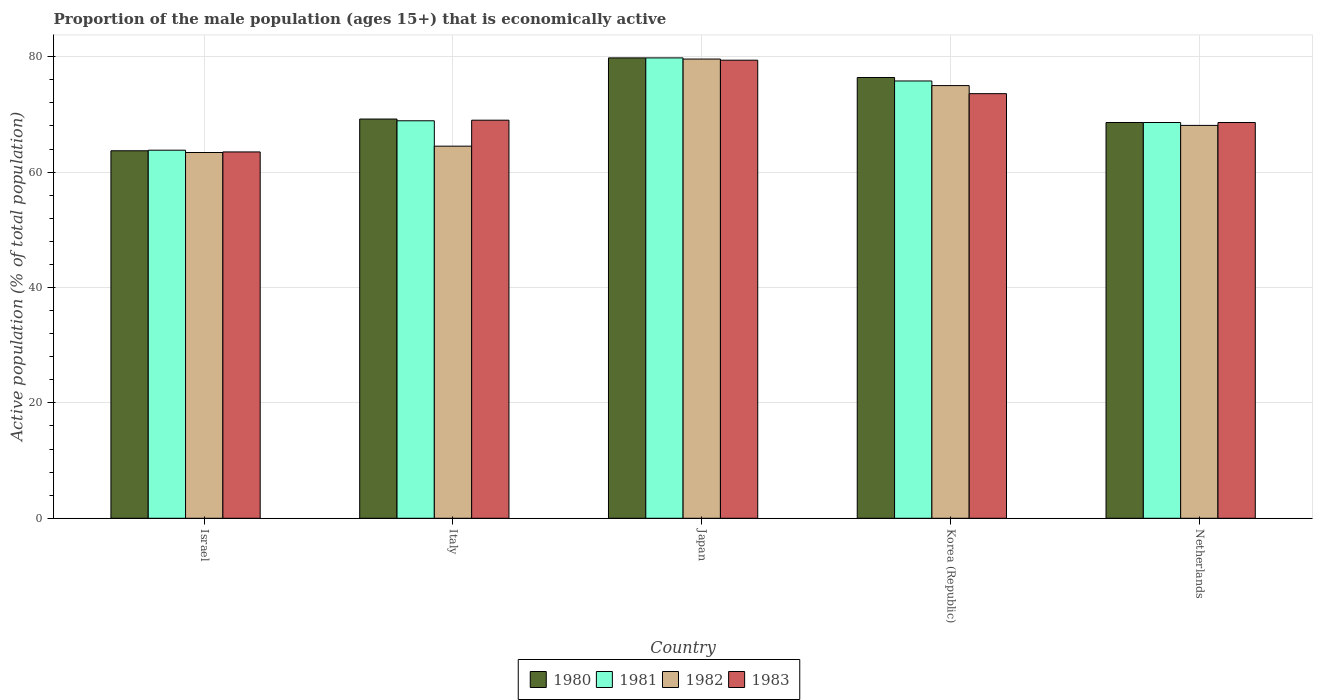How many groups of bars are there?
Ensure brevity in your answer.  5. How many bars are there on the 2nd tick from the left?
Your answer should be compact. 4. What is the label of the 2nd group of bars from the left?
Provide a succinct answer. Italy. What is the proportion of the male population that is economically active in 1983 in Israel?
Ensure brevity in your answer.  63.5. Across all countries, what is the maximum proportion of the male population that is economically active in 1983?
Keep it short and to the point. 79.4. Across all countries, what is the minimum proportion of the male population that is economically active in 1981?
Provide a short and direct response. 63.8. In which country was the proportion of the male population that is economically active in 1983 minimum?
Your response must be concise. Israel. What is the total proportion of the male population that is economically active in 1983 in the graph?
Your answer should be compact. 354.1. What is the difference between the proportion of the male population that is economically active in 1982 in Italy and that in Japan?
Give a very brief answer. -15.1. What is the difference between the proportion of the male population that is economically active in 1983 in Japan and the proportion of the male population that is economically active in 1982 in Netherlands?
Your response must be concise. 11.3. What is the average proportion of the male population that is economically active in 1980 per country?
Offer a very short reply. 71.54. What is the difference between the proportion of the male population that is economically active of/in 1980 and proportion of the male population that is economically active of/in 1983 in Japan?
Your answer should be compact. 0.4. What is the ratio of the proportion of the male population that is economically active in 1982 in Italy to that in Japan?
Offer a very short reply. 0.81. Is the proportion of the male population that is economically active in 1980 in Israel less than that in Japan?
Ensure brevity in your answer.  Yes. What is the difference between the highest and the second highest proportion of the male population that is economically active in 1981?
Your answer should be compact. 6.9. What is the difference between the highest and the lowest proportion of the male population that is economically active in 1980?
Offer a terse response. 16.1. Is the sum of the proportion of the male population that is economically active in 1980 in Israel and Japan greater than the maximum proportion of the male population that is economically active in 1983 across all countries?
Offer a very short reply. Yes. What does the 2nd bar from the right in Japan represents?
Offer a terse response. 1982. How many bars are there?
Offer a terse response. 20. Are the values on the major ticks of Y-axis written in scientific E-notation?
Give a very brief answer. No. What is the title of the graph?
Your answer should be very brief. Proportion of the male population (ages 15+) that is economically active. What is the label or title of the Y-axis?
Offer a terse response. Active population (% of total population). What is the Active population (% of total population) of 1980 in Israel?
Ensure brevity in your answer.  63.7. What is the Active population (% of total population) of 1981 in Israel?
Your answer should be compact. 63.8. What is the Active population (% of total population) of 1982 in Israel?
Your response must be concise. 63.4. What is the Active population (% of total population) of 1983 in Israel?
Give a very brief answer. 63.5. What is the Active population (% of total population) in 1980 in Italy?
Give a very brief answer. 69.2. What is the Active population (% of total population) in 1981 in Italy?
Your response must be concise. 68.9. What is the Active population (% of total population) of 1982 in Italy?
Your response must be concise. 64.5. What is the Active population (% of total population) of 1983 in Italy?
Give a very brief answer. 69. What is the Active population (% of total population) of 1980 in Japan?
Your answer should be very brief. 79.8. What is the Active population (% of total population) of 1981 in Japan?
Your answer should be compact. 79.8. What is the Active population (% of total population) of 1982 in Japan?
Make the answer very short. 79.6. What is the Active population (% of total population) in 1983 in Japan?
Ensure brevity in your answer.  79.4. What is the Active population (% of total population) in 1980 in Korea (Republic)?
Make the answer very short. 76.4. What is the Active population (% of total population) in 1981 in Korea (Republic)?
Ensure brevity in your answer.  75.8. What is the Active population (% of total population) in 1983 in Korea (Republic)?
Your answer should be very brief. 73.6. What is the Active population (% of total population) in 1980 in Netherlands?
Give a very brief answer. 68.6. What is the Active population (% of total population) in 1981 in Netherlands?
Offer a very short reply. 68.6. What is the Active population (% of total population) of 1982 in Netherlands?
Ensure brevity in your answer.  68.1. What is the Active population (% of total population) of 1983 in Netherlands?
Provide a succinct answer. 68.6. Across all countries, what is the maximum Active population (% of total population) in 1980?
Your answer should be compact. 79.8. Across all countries, what is the maximum Active population (% of total population) of 1981?
Make the answer very short. 79.8. Across all countries, what is the maximum Active population (% of total population) in 1982?
Keep it short and to the point. 79.6. Across all countries, what is the maximum Active population (% of total population) in 1983?
Make the answer very short. 79.4. Across all countries, what is the minimum Active population (% of total population) of 1980?
Give a very brief answer. 63.7. Across all countries, what is the minimum Active population (% of total population) of 1981?
Offer a terse response. 63.8. Across all countries, what is the minimum Active population (% of total population) of 1982?
Make the answer very short. 63.4. Across all countries, what is the minimum Active population (% of total population) in 1983?
Offer a very short reply. 63.5. What is the total Active population (% of total population) of 1980 in the graph?
Provide a short and direct response. 357.7. What is the total Active population (% of total population) in 1981 in the graph?
Provide a succinct answer. 356.9. What is the total Active population (% of total population) of 1982 in the graph?
Ensure brevity in your answer.  350.6. What is the total Active population (% of total population) of 1983 in the graph?
Your response must be concise. 354.1. What is the difference between the Active population (% of total population) of 1980 in Israel and that in Italy?
Keep it short and to the point. -5.5. What is the difference between the Active population (% of total population) of 1982 in Israel and that in Italy?
Your answer should be very brief. -1.1. What is the difference between the Active population (% of total population) of 1980 in Israel and that in Japan?
Provide a succinct answer. -16.1. What is the difference between the Active population (% of total population) in 1981 in Israel and that in Japan?
Ensure brevity in your answer.  -16. What is the difference between the Active population (% of total population) of 1982 in Israel and that in Japan?
Your answer should be very brief. -16.2. What is the difference between the Active population (% of total population) of 1983 in Israel and that in Japan?
Keep it short and to the point. -15.9. What is the difference between the Active population (% of total population) in 1980 in Israel and that in Korea (Republic)?
Your answer should be compact. -12.7. What is the difference between the Active population (% of total population) in 1982 in Israel and that in Korea (Republic)?
Offer a very short reply. -11.6. What is the difference between the Active population (% of total population) in 1983 in Israel and that in Korea (Republic)?
Keep it short and to the point. -10.1. What is the difference between the Active population (% of total population) of 1980 in Israel and that in Netherlands?
Keep it short and to the point. -4.9. What is the difference between the Active population (% of total population) in 1981 in Israel and that in Netherlands?
Make the answer very short. -4.8. What is the difference between the Active population (% of total population) of 1982 in Israel and that in Netherlands?
Your answer should be very brief. -4.7. What is the difference between the Active population (% of total population) of 1982 in Italy and that in Japan?
Your answer should be compact. -15.1. What is the difference between the Active population (% of total population) in 1983 in Italy and that in Japan?
Your response must be concise. -10.4. What is the difference between the Active population (% of total population) of 1981 in Italy and that in Korea (Republic)?
Provide a short and direct response. -6.9. What is the difference between the Active population (% of total population) in 1982 in Italy and that in Korea (Republic)?
Your response must be concise. -10.5. What is the difference between the Active population (% of total population) in 1980 in Italy and that in Netherlands?
Keep it short and to the point. 0.6. What is the difference between the Active population (% of total population) in 1981 in Italy and that in Netherlands?
Ensure brevity in your answer.  0.3. What is the difference between the Active population (% of total population) of 1982 in Italy and that in Netherlands?
Your answer should be very brief. -3.6. What is the difference between the Active population (% of total population) in 1983 in Italy and that in Netherlands?
Offer a very short reply. 0.4. What is the difference between the Active population (% of total population) in 1983 in Japan and that in Korea (Republic)?
Make the answer very short. 5.8. What is the difference between the Active population (% of total population) of 1980 in Japan and that in Netherlands?
Ensure brevity in your answer.  11.2. What is the difference between the Active population (% of total population) in 1982 in Japan and that in Netherlands?
Provide a short and direct response. 11.5. What is the difference between the Active population (% of total population) of 1983 in Japan and that in Netherlands?
Ensure brevity in your answer.  10.8. What is the difference between the Active population (% of total population) of 1980 in Korea (Republic) and that in Netherlands?
Make the answer very short. 7.8. What is the difference between the Active population (% of total population) of 1982 in Korea (Republic) and that in Netherlands?
Your answer should be very brief. 6.9. What is the difference between the Active population (% of total population) in 1983 in Korea (Republic) and that in Netherlands?
Ensure brevity in your answer.  5. What is the difference between the Active population (% of total population) in 1980 in Israel and the Active population (% of total population) in 1983 in Italy?
Your answer should be very brief. -5.3. What is the difference between the Active population (% of total population) in 1981 in Israel and the Active population (% of total population) in 1982 in Italy?
Provide a short and direct response. -0.7. What is the difference between the Active population (% of total population) in 1981 in Israel and the Active population (% of total population) in 1983 in Italy?
Keep it short and to the point. -5.2. What is the difference between the Active population (% of total population) of 1982 in Israel and the Active population (% of total population) of 1983 in Italy?
Your answer should be compact. -5.6. What is the difference between the Active population (% of total population) in 1980 in Israel and the Active population (% of total population) in 1981 in Japan?
Offer a terse response. -16.1. What is the difference between the Active population (% of total population) in 1980 in Israel and the Active population (% of total population) in 1982 in Japan?
Ensure brevity in your answer.  -15.9. What is the difference between the Active population (% of total population) in 1980 in Israel and the Active population (% of total population) in 1983 in Japan?
Your answer should be compact. -15.7. What is the difference between the Active population (% of total population) in 1981 in Israel and the Active population (% of total population) in 1982 in Japan?
Give a very brief answer. -15.8. What is the difference between the Active population (% of total population) in 1981 in Israel and the Active population (% of total population) in 1983 in Japan?
Your answer should be very brief. -15.6. What is the difference between the Active population (% of total population) of 1980 in Israel and the Active population (% of total population) of 1981 in Korea (Republic)?
Provide a succinct answer. -12.1. What is the difference between the Active population (% of total population) in 1980 in Israel and the Active population (% of total population) in 1983 in Korea (Republic)?
Give a very brief answer. -9.9. What is the difference between the Active population (% of total population) of 1980 in Israel and the Active population (% of total population) of 1983 in Netherlands?
Keep it short and to the point. -4.9. What is the difference between the Active population (% of total population) in 1981 in Israel and the Active population (% of total population) in 1982 in Netherlands?
Your answer should be compact. -4.3. What is the difference between the Active population (% of total population) in 1982 in Israel and the Active population (% of total population) in 1983 in Netherlands?
Provide a short and direct response. -5.2. What is the difference between the Active population (% of total population) of 1981 in Italy and the Active population (% of total population) of 1983 in Japan?
Your answer should be very brief. -10.5. What is the difference between the Active population (% of total population) in 1982 in Italy and the Active population (% of total population) in 1983 in Japan?
Your response must be concise. -14.9. What is the difference between the Active population (% of total population) of 1980 in Italy and the Active population (% of total population) of 1981 in Korea (Republic)?
Your response must be concise. -6.6. What is the difference between the Active population (% of total population) in 1980 in Italy and the Active population (% of total population) in 1983 in Korea (Republic)?
Your answer should be compact. -4.4. What is the difference between the Active population (% of total population) in 1981 in Italy and the Active population (% of total population) in 1982 in Korea (Republic)?
Provide a succinct answer. -6.1. What is the difference between the Active population (% of total population) in 1980 in Italy and the Active population (% of total population) in 1983 in Netherlands?
Offer a terse response. 0.6. What is the difference between the Active population (% of total population) in 1981 in Italy and the Active population (% of total population) in 1983 in Netherlands?
Keep it short and to the point. 0.3. What is the difference between the Active population (% of total population) of 1982 in Italy and the Active population (% of total population) of 1983 in Netherlands?
Your answer should be compact. -4.1. What is the difference between the Active population (% of total population) in 1980 in Japan and the Active population (% of total population) in 1982 in Korea (Republic)?
Offer a very short reply. 4.8. What is the difference between the Active population (% of total population) in 1981 in Japan and the Active population (% of total population) in 1983 in Korea (Republic)?
Offer a very short reply. 6.2. What is the difference between the Active population (% of total population) in 1982 in Japan and the Active population (% of total population) in 1983 in Korea (Republic)?
Provide a succinct answer. 6. What is the difference between the Active population (% of total population) of 1980 in Japan and the Active population (% of total population) of 1982 in Netherlands?
Your answer should be very brief. 11.7. What is the difference between the Active population (% of total population) in 1980 in Japan and the Active population (% of total population) in 1983 in Netherlands?
Make the answer very short. 11.2. What is the difference between the Active population (% of total population) in 1981 in Japan and the Active population (% of total population) in 1983 in Netherlands?
Your response must be concise. 11.2. What is the difference between the Active population (% of total population) in 1982 in Japan and the Active population (% of total population) in 1983 in Netherlands?
Provide a short and direct response. 11. What is the difference between the Active population (% of total population) of 1980 in Korea (Republic) and the Active population (% of total population) of 1981 in Netherlands?
Keep it short and to the point. 7.8. What is the difference between the Active population (% of total population) of 1981 in Korea (Republic) and the Active population (% of total population) of 1983 in Netherlands?
Your answer should be compact. 7.2. What is the average Active population (% of total population) of 1980 per country?
Ensure brevity in your answer.  71.54. What is the average Active population (% of total population) of 1981 per country?
Your answer should be compact. 71.38. What is the average Active population (% of total population) of 1982 per country?
Ensure brevity in your answer.  70.12. What is the average Active population (% of total population) in 1983 per country?
Keep it short and to the point. 70.82. What is the difference between the Active population (% of total population) of 1980 and Active population (% of total population) of 1981 in Israel?
Your answer should be very brief. -0.1. What is the difference between the Active population (% of total population) in 1980 and Active population (% of total population) in 1982 in Israel?
Your response must be concise. 0.3. What is the difference between the Active population (% of total population) in 1980 and Active population (% of total population) in 1983 in Israel?
Provide a succinct answer. 0.2. What is the difference between the Active population (% of total population) in 1981 and Active population (% of total population) in 1982 in Israel?
Make the answer very short. 0.4. What is the difference between the Active population (% of total population) in 1981 and Active population (% of total population) in 1983 in Israel?
Offer a very short reply. 0.3. What is the difference between the Active population (% of total population) in 1980 and Active population (% of total population) in 1982 in Italy?
Your answer should be compact. 4.7. What is the difference between the Active population (% of total population) in 1981 and Active population (% of total population) in 1982 in Italy?
Offer a terse response. 4.4. What is the difference between the Active population (% of total population) of 1981 and Active population (% of total population) of 1983 in Italy?
Ensure brevity in your answer.  -0.1. What is the difference between the Active population (% of total population) in 1980 and Active population (% of total population) in 1981 in Japan?
Provide a succinct answer. 0. What is the difference between the Active population (% of total population) in 1980 and Active population (% of total population) in 1982 in Japan?
Provide a succinct answer. 0.2. What is the difference between the Active population (% of total population) in 1980 and Active population (% of total population) in 1983 in Japan?
Your answer should be very brief. 0.4. What is the difference between the Active population (% of total population) of 1981 and Active population (% of total population) of 1983 in Japan?
Offer a terse response. 0.4. What is the difference between the Active population (% of total population) in 1980 and Active population (% of total population) in 1982 in Korea (Republic)?
Provide a succinct answer. 1.4. What is the difference between the Active population (% of total population) of 1981 and Active population (% of total population) of 1982 in Korea (Republic)?
Offer a very short reply. 0.8. What is the difference between the Active population (% of total population) in 1981 and Active population (% of total population) in 1983 in Korea (Republic)?
Your answer should be very brief. 2.2. What is the difference between the Active population (% of total population) in 1982 and Active population (% of total population) in 1983 in Korea (Republic)?
Provide a short and direct response. 1.4. What is the difference between the Active population (% of total population) in 1980 and Active population (% of total population) in 1982 in Netherlands?
Provide a succinct answer. 0.5. What is the difference between the Active population (% of total population) of 1981 and Active population (% of total population) of 1982 in Netherlands?
Give a very brief answer. 0.5. What is the difference between the Active population (% of total population) of 1981 and Active population (% of total population) of 1983 in Netherlands?
Keep it short and to the point. 0. What is the ratio of the Active population (% of total population) in 1980 in Israel to that in Italy?
Your response must be concise. 0.92. What is the ratio of the Active population (% of total population) of 1981 in Israel to that in Italy?
Ensure brevity in your answer.  0.93. What is the ratio of the Active population (% of total population) in 1982 in Israel to that in Italy?
Make the answer very short. 0.98. What is the ratio of the Active population (% of total population) of 1983 in Israel to that in Italy?
Your answer should be compact. 0.92. What is the ratio of the Active population (% of total population) of 1980 in Israel to that in Japan?
Keep it short and to the point. 0.8. What is the ratio of the Active population (% of total population) of 1981 in Israel to that in Japan?
Offer a very short reply. 0.8. What is the ratio of the Active population (% of total population) in 1982 in Israel to that in Japan?
Provide a succinct answer. 0.8. What is the ratio of the Active population (% of total population) of 1983 in Israel to that in Japan?
Give a very brief answer. 0.8. What is the ratio of the Active population (% of total population) in 1980 in Israel to that in Korea (Republic)?
Provide a short and direct response. 0.83. What is the ratio of the Active population (% of total population) of 1981 in Israel to that in Korea (Republic)?
Keep it short and to the point. 0.84. What is the ratio of the Active population (% of total population) in 1982 in Israel to that in Korea (Republic)?
Keep it short and to the point. 0.85. What is the ratio of the Active population (% of total population) of 1983 in Israel to that in Korea (Republic)?
Offer a terse response. 0.86. What is the ratio of the Active population (% of total population) of 1980 in Israel to that in Netherlands?
Your answer should be very brief. 0.93. What is the ratio of the Active population (% of total population) of 1981 in Israel to that in Netherlands?
Offer a very short reply. 0.93. What is the ratio of the Active population (% of total population) of 1983 in Israel to that in Netherlands?
Provide a short and direct response. 0.93. What is the ratio of the Active population (% of total population) of 1980 in Italy to that in Japan?
Offer a terse response. 0.87. What is the ratio of the Active population (% of total population) in 1981 in Italy to that in Japan?
Provide a succinct answer. 0.86. What is the ratio of the Active population (% of total population) of 1982 in Italy to that in Japan?
Offer a very short reply. 0.81. What is the ratio of the Active population (% of total population) in 1983 in Italy to that in Japan?
Keep it short and to the point. 0.87. What is the ratio of the Active population (% of total population) in 1980 in Italy to that in Korea (Republic)?
Keep it short and to the point. 0.91. What is the ratio of the Active population (% of total population) in 1981 in Italy to that in Korea (Republic)?
Offer a terse response. 0.91. What is the ratio of the Active population (% of total population) in 1982 in Italy to that in Korea (Republic)?
Provide a succinct answer. 0.86. What is the ratio of the Active population (% of total population) in 1980 in Italy to that in Netherlands?
Your answer should be compact. 1.01. What is the ratio of the Active population (% of total population) of 1982 in Italy to that in Netherlands?
Your response must be concise. 0.95. What is the ratio of the Active population (% of total population) of 1983 in Italy to that in Netherlands?
Ensure brevity in your answer.  1.01. What is the ratio of the Active population (% of total population) of 1980 in Japan to that in Korea (Republic)?
Provide a short and direct response. 1.04. What is the ratio of the Active population (% of total population) in 1981 in Japan to that in Korea (Republic)?
Make the answer very short. 1.05. What is the ratio of the Active population (% of total population) of 1982 in Japan to that in Korea (Republic)?
Make the answer very short. 1.06. What is the ratio of the Active population (% of total population) of 1983 in Japan to that in Korea (Republic)?
Provide a short and direct response. 1.08. What is the ratio of the Active population (% of total population) of 1980 in Japan to that in Netherlands?
Give a very brief answer. 1.16. What is the ratio of the Active population (% of total population) of 1981 in Japan to that in Netherlands?
Give a very brief answer. 1.16. What is the ratio of the Active population (% of total population) of 1982 in Japan to that in Netherlands?
Provide a short and direct response. 1.17. What is the ratio of the Active population (% of total population) in 1983 in Japan to that in Netherlands?
Ensure brevity in your answer.  1.16. What is the ratio of the Active population (% of total population) of 1980 in Korea (Republic) to that in Netherlands?
Give a very brief answer. 1.11. What is the ratio of the Active population (% of total population) of 1981 in Korea (Republic) to that in Netherlands?
Provide a short and direct response. 1.1. What is the ratio of the Active population (% of total population) in 1982 in Korea (Republic) to that in Netherlands?
Provide a succinct answer. 1.1. What is the ratio of the Active population (% of total population) of 1983 in Korea (Republic) to that in Netherlands?
Provide a short and direct response. 1.07. What is the difference between the highest and the second highest Active population (% of total population) of 1981?
Provide a short and direct response. 4. What is the difference between the highest and the second highest Active population (% of total population) of 1983?
Make the answer very short. 5.8. What is the difference between the highest and the lowest Active population (% of total population) in 1982?
Keep it short and to the point. 16.2. 